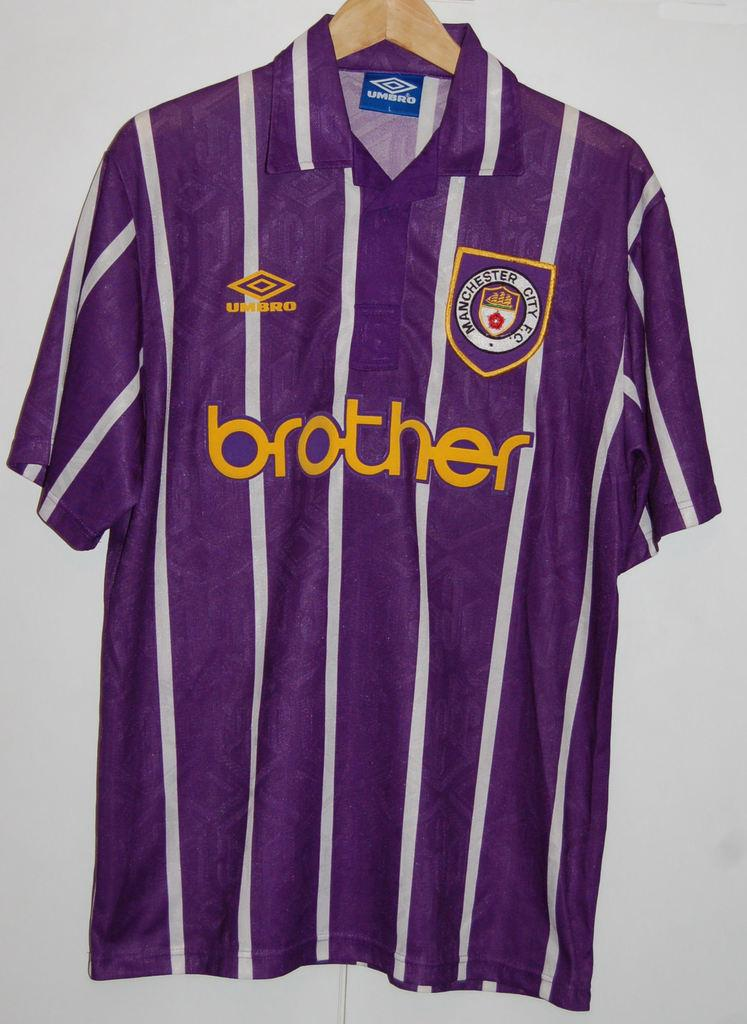<image>
Present a compact description of the photo's key features. Striped jersey which as the word Brother in the front. 